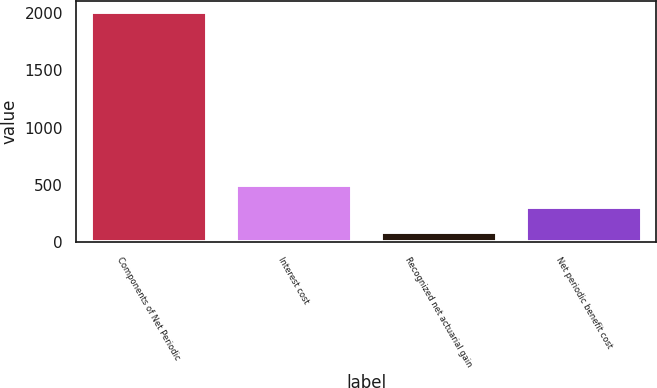Convert chart. <chart><loc_0><loc_0><loc_500><loc_500><bar_chart><fcel>Components of Net Periodic<fcel>Interest cost<fcel>Recognized net actuarial gain<fcel>Net periodic benefit cost<nl><fcel>2007<fcel>497.6<fcel>91<fcel>306<nl></chart> 